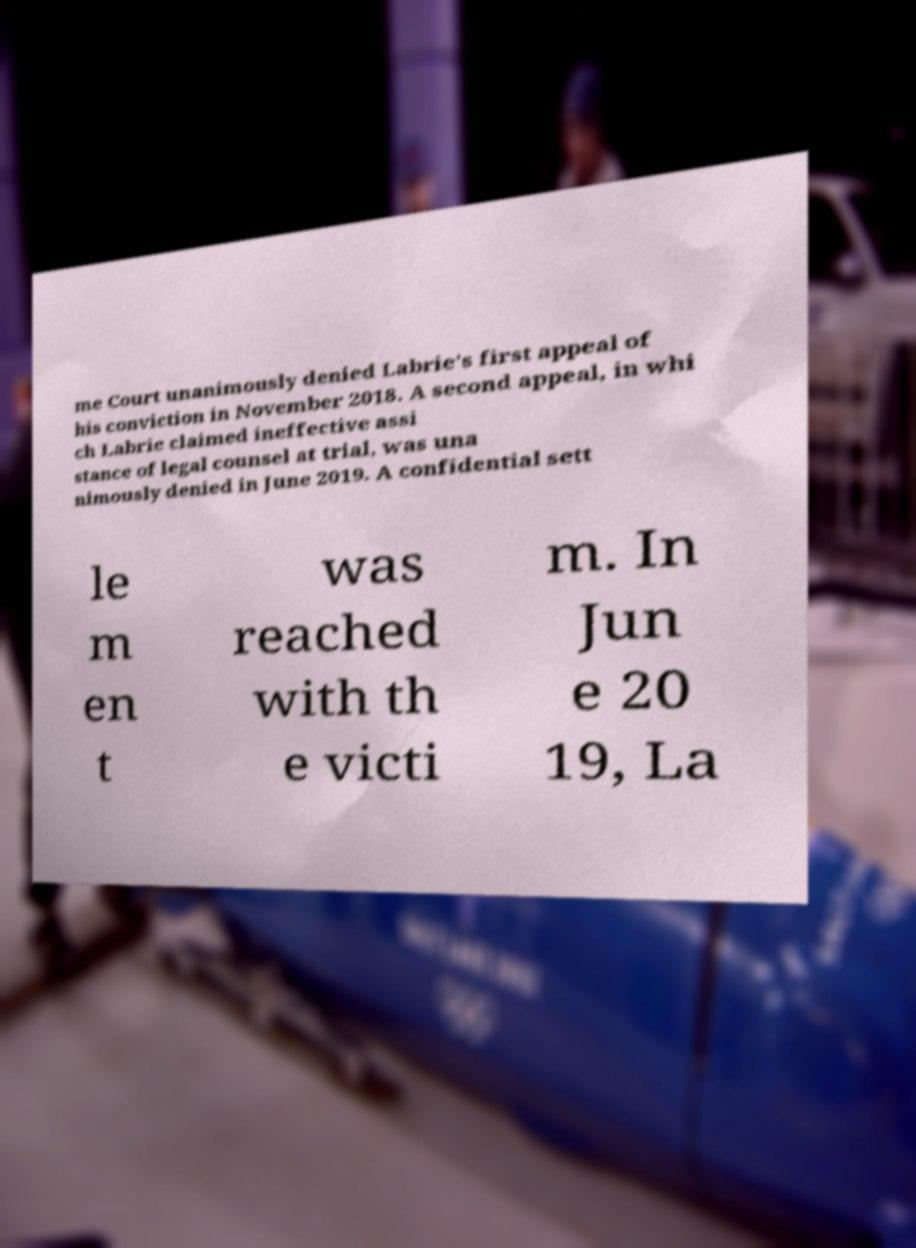For documentation purposes, I need the text within this image transcribed. Could you provide that? me Court unanimously denied Labrie's first appeal of his conviction in November 2018. A second appeal, in whi ch Labrie claimed ineffective assi stance of legal counsel at trial, was una nimously denied in June 2019. A confidential sett le m en t was reached with th e victi m. In Jun e 20 19, La 